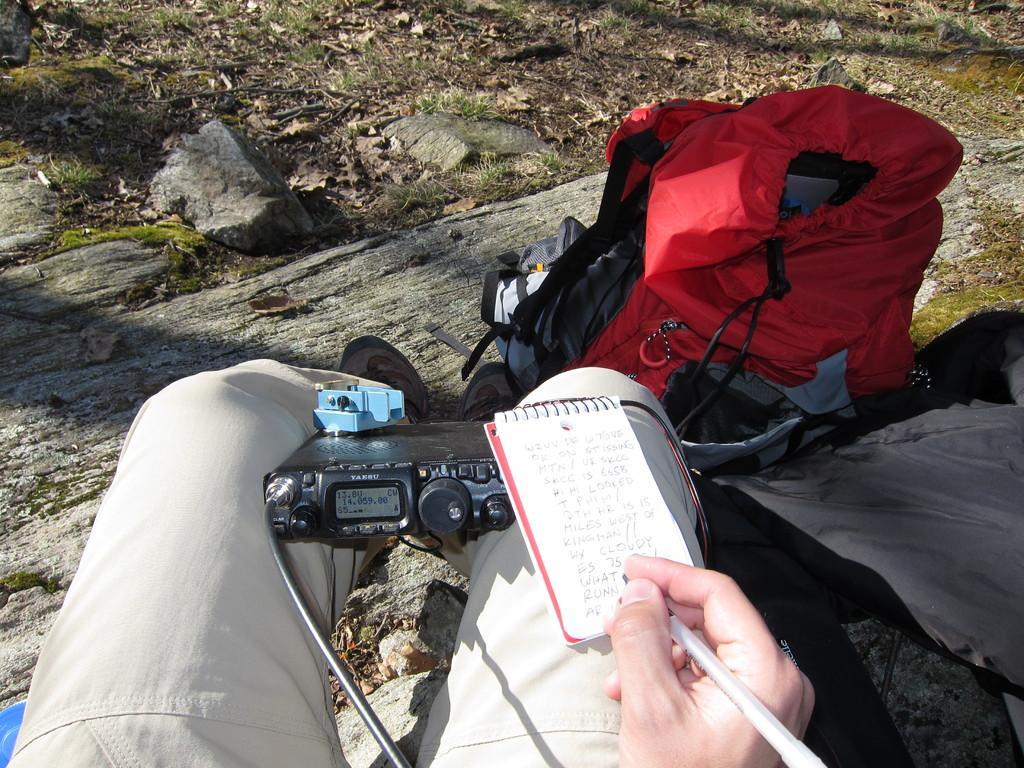Can you describe this image briefly? In this image, There is a person wearing clothes and footwear. This person holding a pen and writing something on the notebook. There is bag which is colored red. There is a controller holding tightly with his legs. 